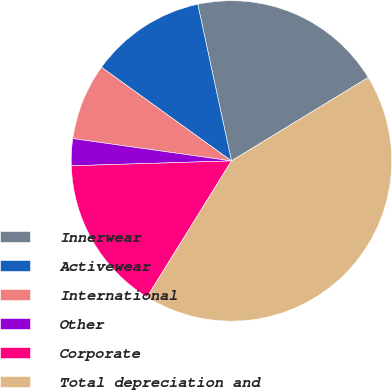Convert chart to OTSL. <chart><loc_0><loc_0><loc_500><loc_500><pie_chart><fcel>Innerwear<fcel>Activewear<fcel>International<fcel>Other<fcel>Corporate<fcel>Total depreciation and<nl><fcel>19.66%<fcel>11.69%<fcel>7.71%<fcel>2.71%<fcel>15.68%<fcel>42.55%<nl></chart> 